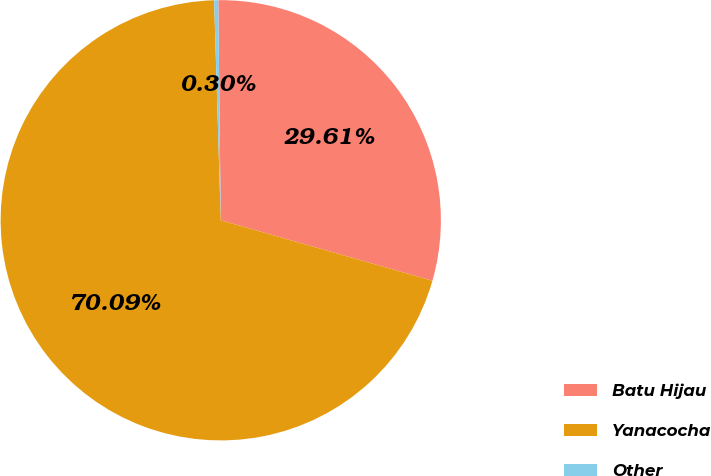Convert chart to OTSL. <chart><loc_0><loc_0><loc_500><loc_500><pie_chart><fcel>Batu Hijau<fcel>Yanacocha<fcel>Other<nl><fcel>29.61%<fcel>70.09%<fcel>0.3%<nl></chart> 